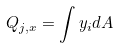<formula> <loc_0><loc_0><loc_500><loc_500>Q _ { j , x } = \int y _ { i } d A</formula> 